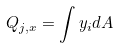<formula> <loc_0><loc_0><loc_500><loc_500>Q _ { j , x } = \int y _ { i } d A</formula> 